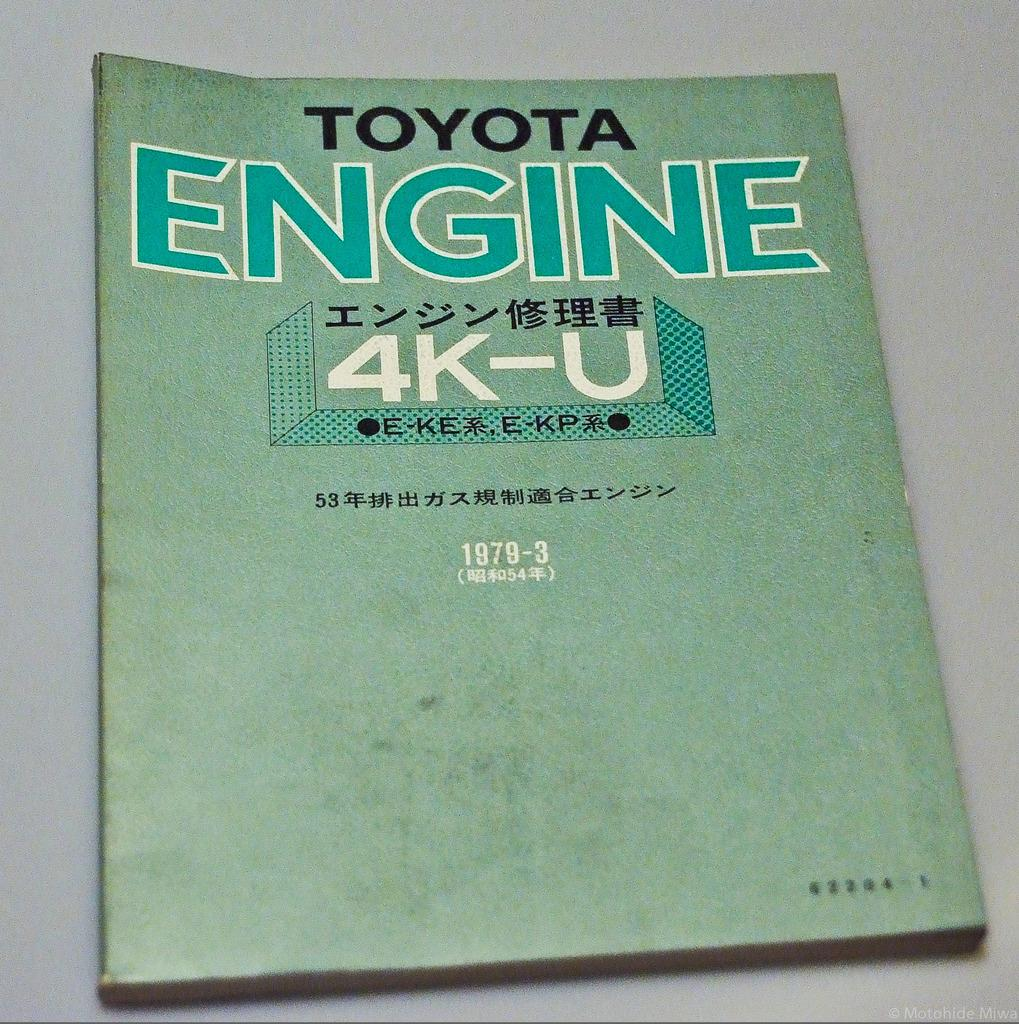<image>
Write a terse but informative summary of the picture. An old green catalog titled Toyota Engine 4K-U. 